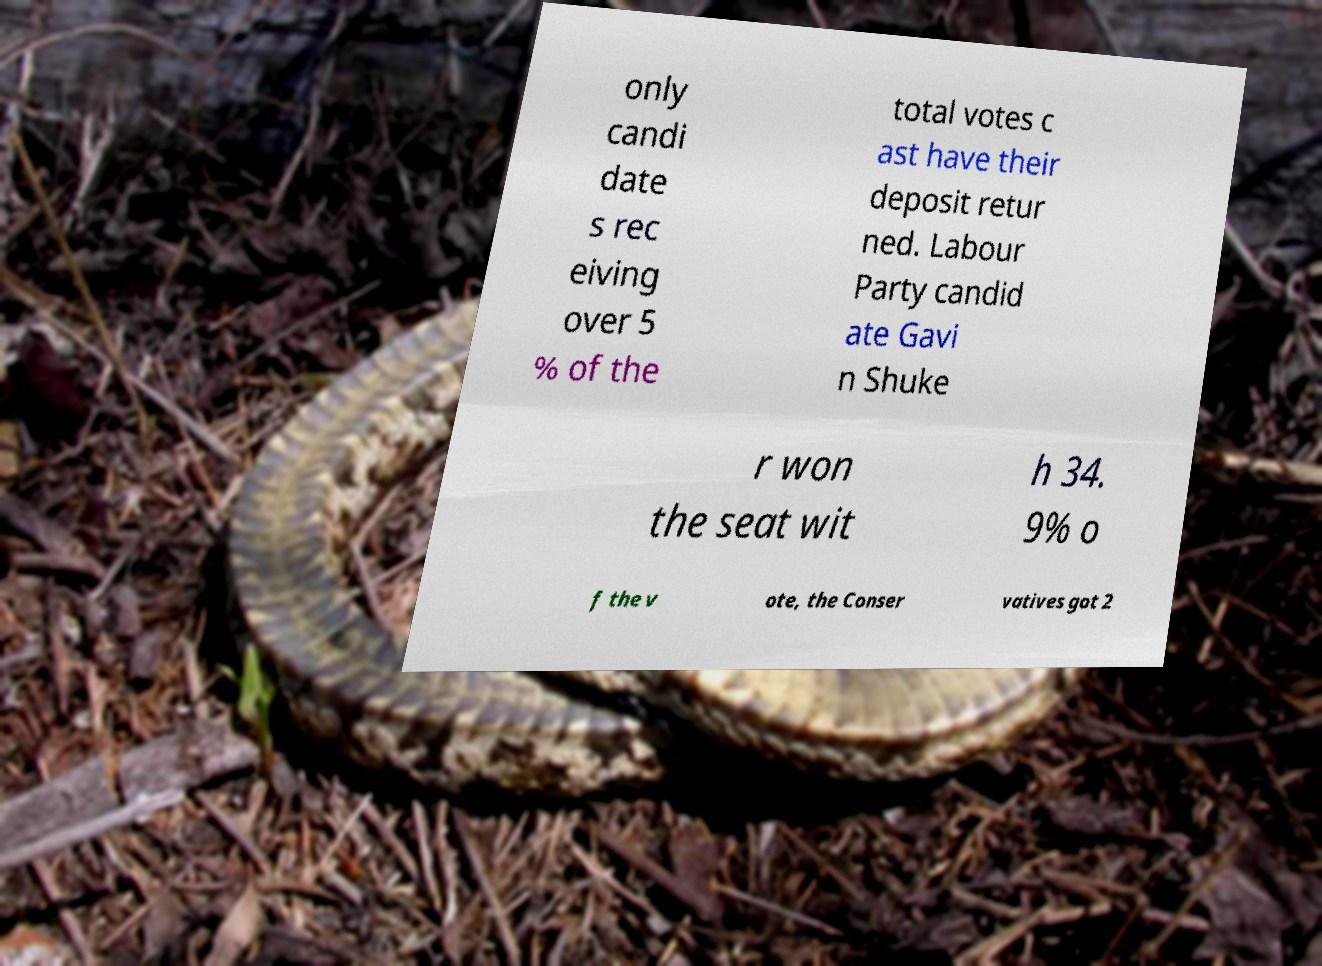Could you assist in decoding the text presented in this image and type it out clearly? only candi date s rec eiving over 5 % of the total votes c ast have their deposit retur ned. Labour Party candid ate Gavi n Shuke r won the seat wit h 34. 9% o f the v ote, the Conser vatives got 2 